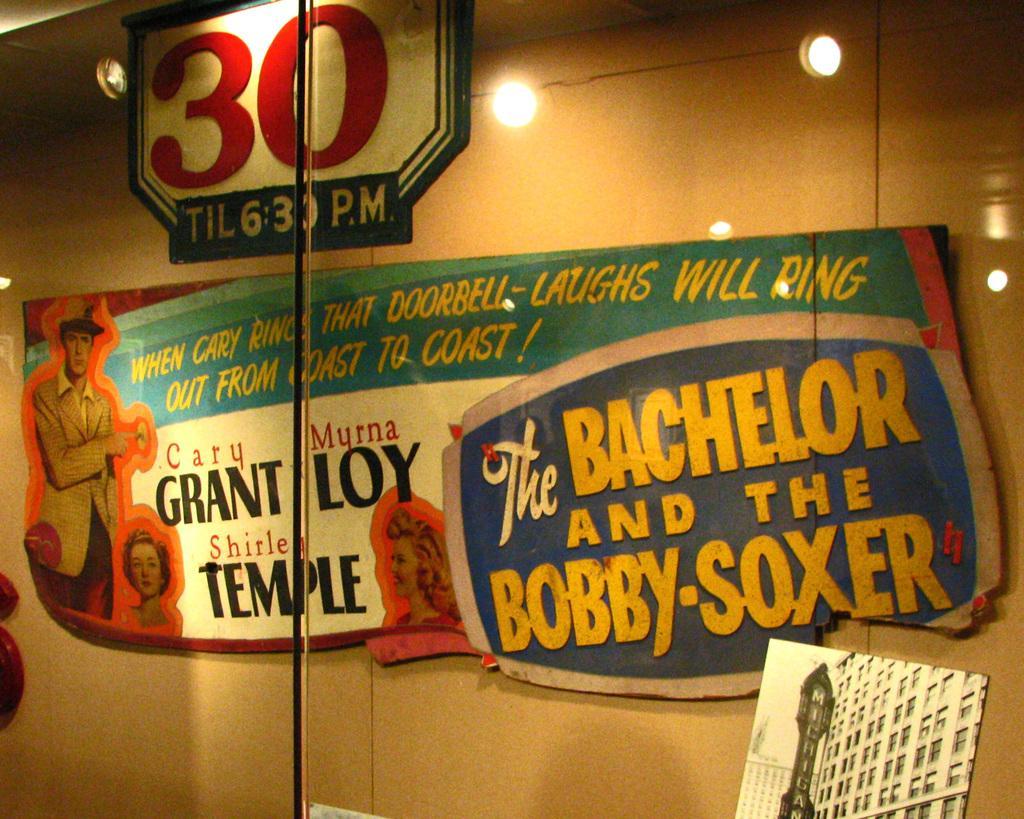Could you give a brief overview of what you see in this image? In this picture we can observe a board fixed to the wall. We can observe some text on this board. There are some lights. In the background there is a wall. 